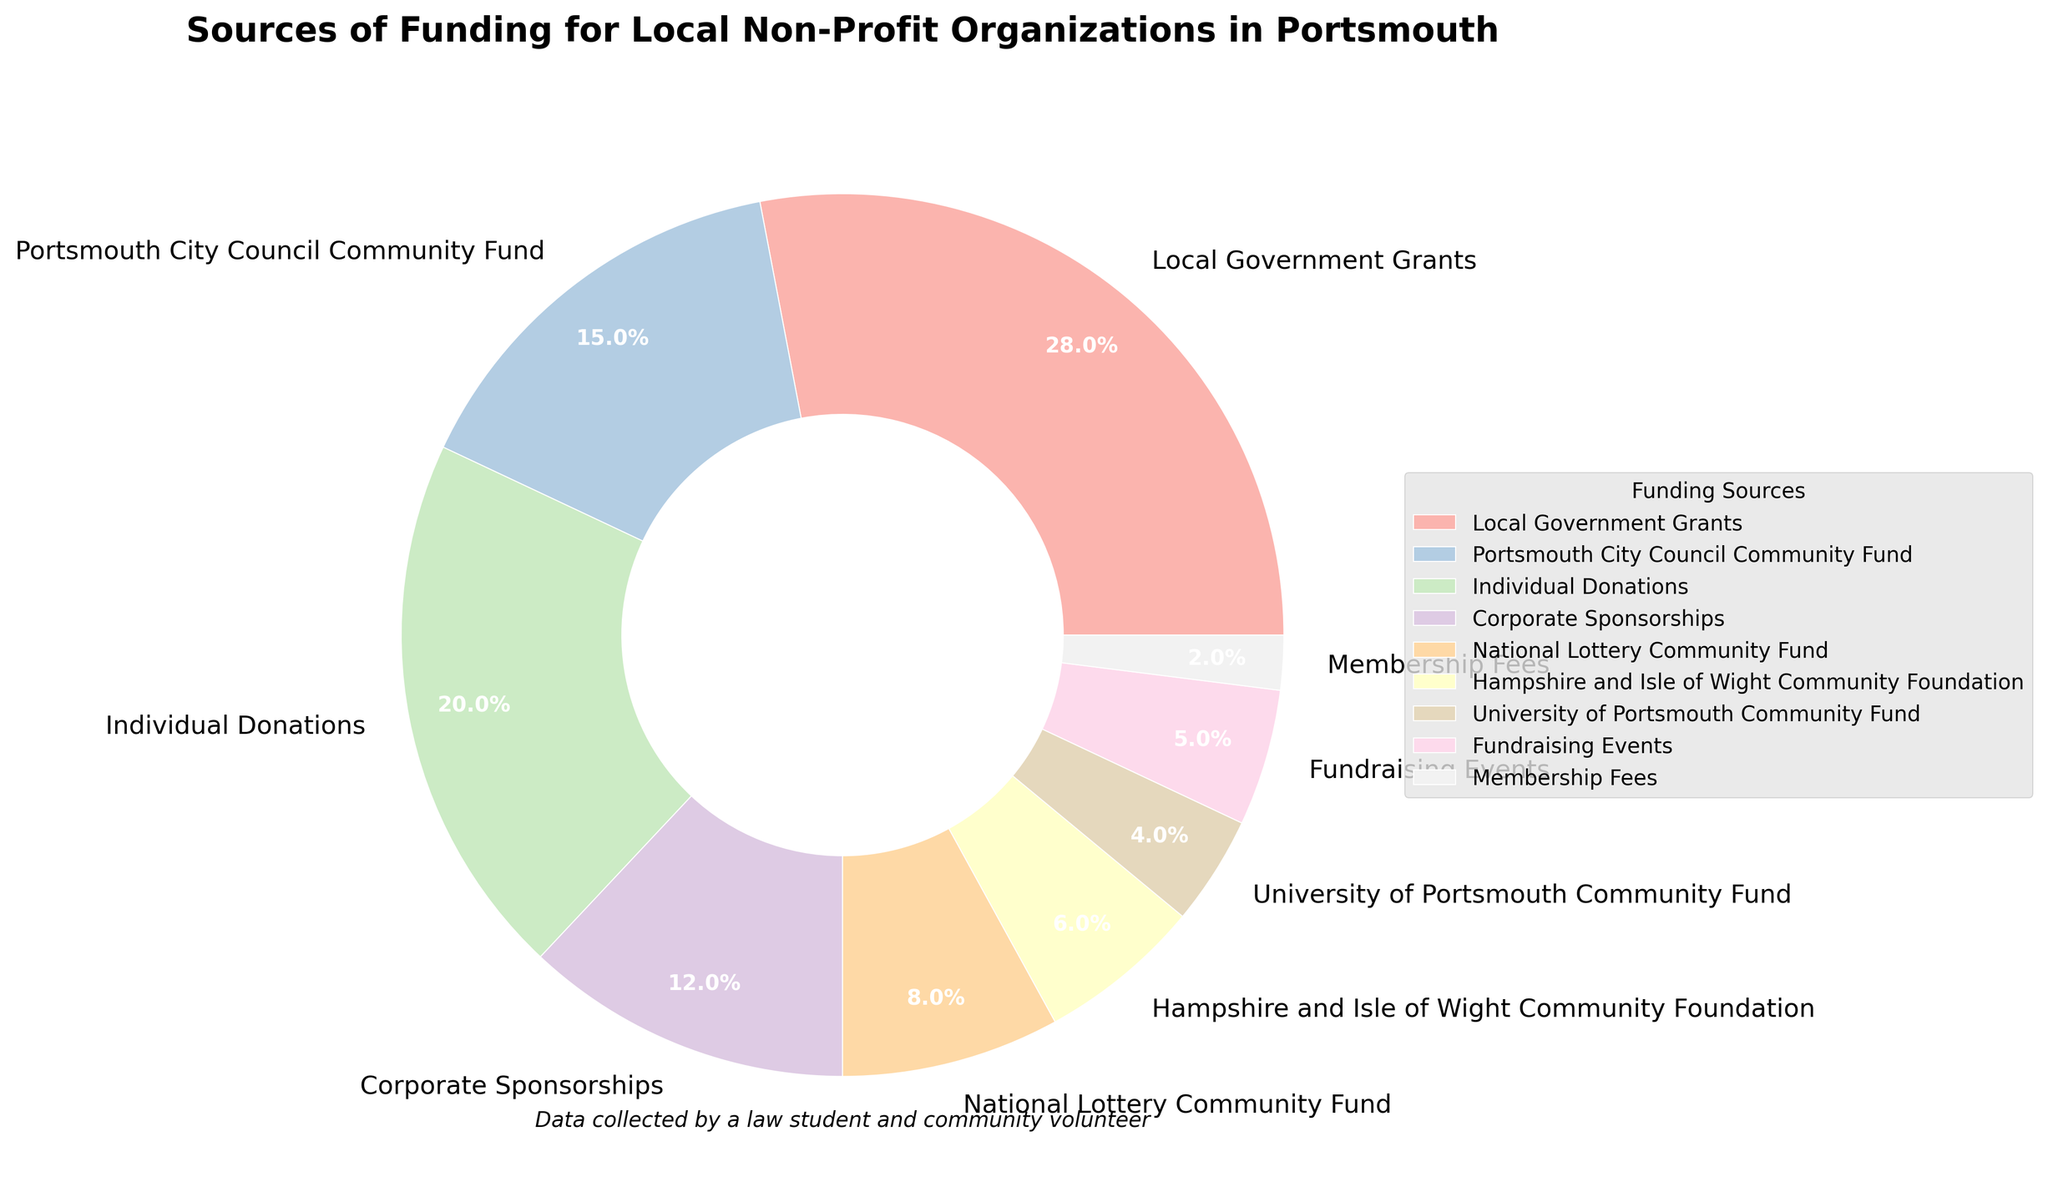What percentage of funding comes from Local Government Grants and Individual Donations combined? To find the combined percentage, add the percentage from Local Government Grants (28%) and Individual Donations (20%). So, 28% + 20% = 48%.
Answer: 48% Which funding source has the second highest contribution? From the pie chart, Local Government Grants (28%) is the highest, followed by Individual Donations (20%). Thus, Individual Donations is the second highest.
Answer: Individual Donations How much more percentage does Local Government Grants contribute than Corporate Sponsorships? The percentage of Local Government Grants is 28%, and Corporate Sponsorships is 12%. To find the difference, subtract 12% from 28%, which is 28% - 12% = 16%.
Answer: 16% What’s the least contributing source of funding? From the pie chart, the smallest segment is represented by Membership Fees at 2%.
Answer: Membership Fees Is the sum of percentages from Corporate Sponsorships and Fundraising Events less than that from Individual Donations? Corporate Sponsorships contribute 12% and Fundraising Events contribute 5%. Their sum is 12% + 5% = 17%. Individual Donations contribute 20%. Since 17% is less than 20%, the answer is yes.
Answer: Yes Which source has a larger contribution, University of Portsmouth Community Fund or Hampshire and Isle of Wight Community Foundation? By comparing the percentages, University of Portsmouth Community Fund has 4%, and Hampshire and Isle of Wight Community Foundation has 6%. Thus, Hampshire and Isle of Wight Community Foundation has a larger contribution.
Answer: Hampshire and Isle of Wight Community Foundation Which segment in the chart is colored the lightest shade? The lightest shade often represents the segment with the smallest percentage contribution in a pastel color palette. The smallest percentage is Membership Fees at 2%.
Answer: Membership Fees What’s the total percentage contributed by Portsmouth City Council Community Fund and National Lottery Community Fund? Adding the contributions from Portsmouth City Council Community Fund (15%) and National Lottery Community Fund (8%) gives 15% + 8% = 23%.
Answer: 23% Is the contribution from Fundraising Events greater than or equal to University of Portsmouth Community Fund? Fundraising Events contribute 5% and University of Portsmouth Community Fund contributes 4%. Since 5% is greater than 4%, the answer is yes.
Answer: Yes 